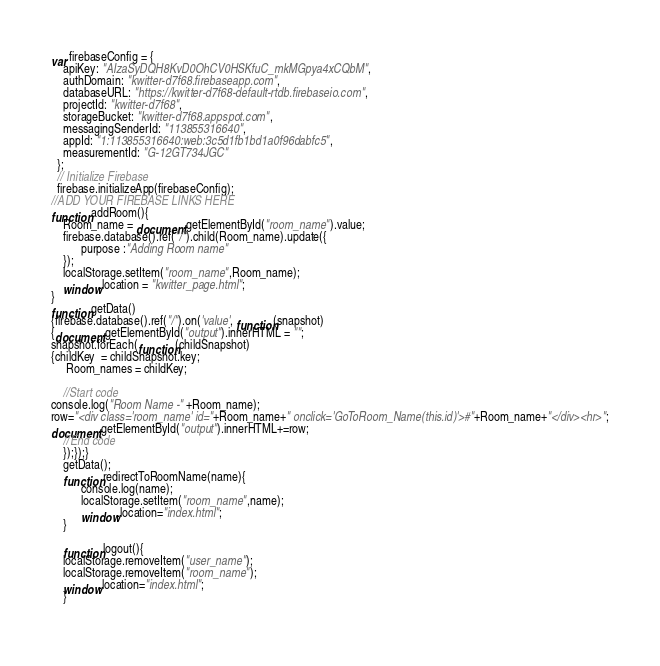<code> <loc_0><loc_0><loc_500><loc_500><_JavaScript_>var firebaseConfig = {
    apiKey: "AIzaSyDQH8KvD0OhCV0HSKfuC_mkMGpya4xCQbM",
    authDomain: "kwitter-d7f68.firebaseapp.com",
    databaseURL: "https://kwitter-d7f68-default-rtdb.firebaseio.com",
    projectId: "kwitter-d7f68",
    storageBucket: "kwitter-d7f68.appspot.com",
    messagingSenderId: "113855316640",
    appId: "1:113855316640:web:3c5d1fb1bd1a0f96dabfc5",
    measurementId: "G-12GT734JGC"
  };
  // Initialize Firebase
  firebase.initializeApp(firebaseConfig);
//ADD YOUR FIREBASE LINKS HERE
function addRoom(){
    Room_name = document.getElementById("room_name").value;
    firebase.database().ref("/").child(Room_name).update({
          purpose :"Adding Room name"
    });
    localStorage.setItem("room_name",Room_name);
    window.location = "kwitter_page.html";
}
function getData()
{firebase.database().ref("/").on('value', function(snapshot) 
{document.getElementById("output").innerHTML = "";
snapshot.forEach(function(childSnapshot) 
{childKey  = childSnapshot.key;
     Room_names = childKey;
     
    //Start code
console.log("Room Name -" +Room_name);
row="<div class='room_name' id="+Room_name+" onclick='GoToRoom_Name(this.id)'>#"+Room_name+"</div><hr>";
document.getElementById("output").innerHTML+=row;
    //End code
    });});}
    getData();
    function redirectToRoomName(name){
          console.log(name);
          localStorage.setItem("room_name",name);
          window.location="index.html";
    }
    
    function logout(){
    localStorage.removeItem("user_name");
    localStorage.removeItem("room_name");
    window.location="index.html";
    }
    </code> 